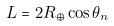Convert formula to latex. <formula><loc_0><loc_0><loc_500><loc_500>L = 2 R _ { \oplus } \cos \theta _ { n }</formula> 